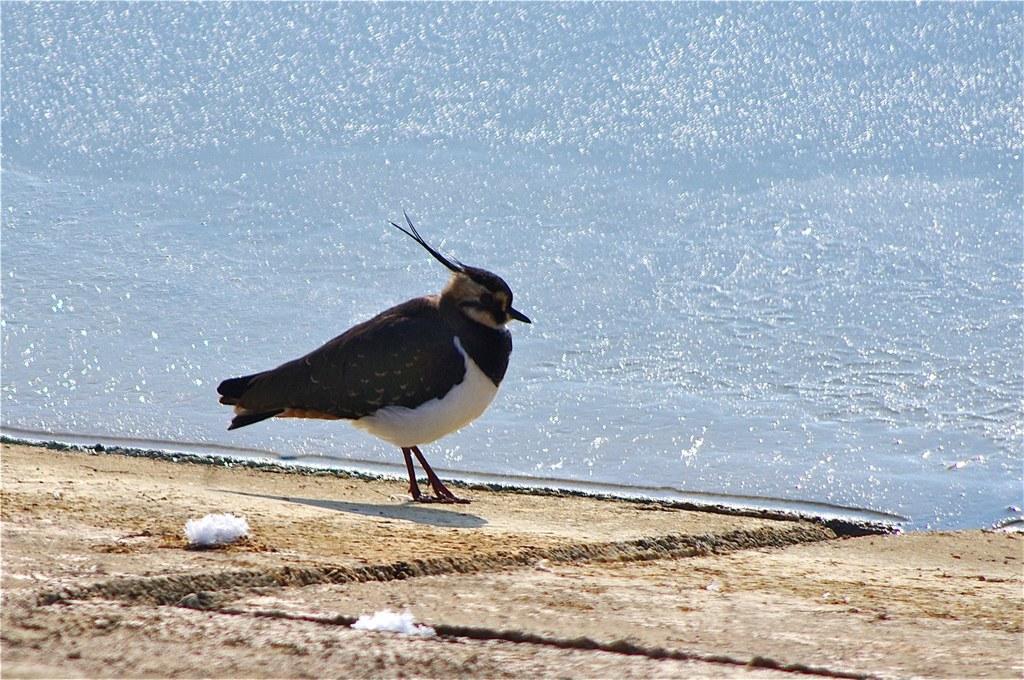How would you summarize this image in a sentence or two? In this image we can see a bird on the land. On the backside we can see the water. 